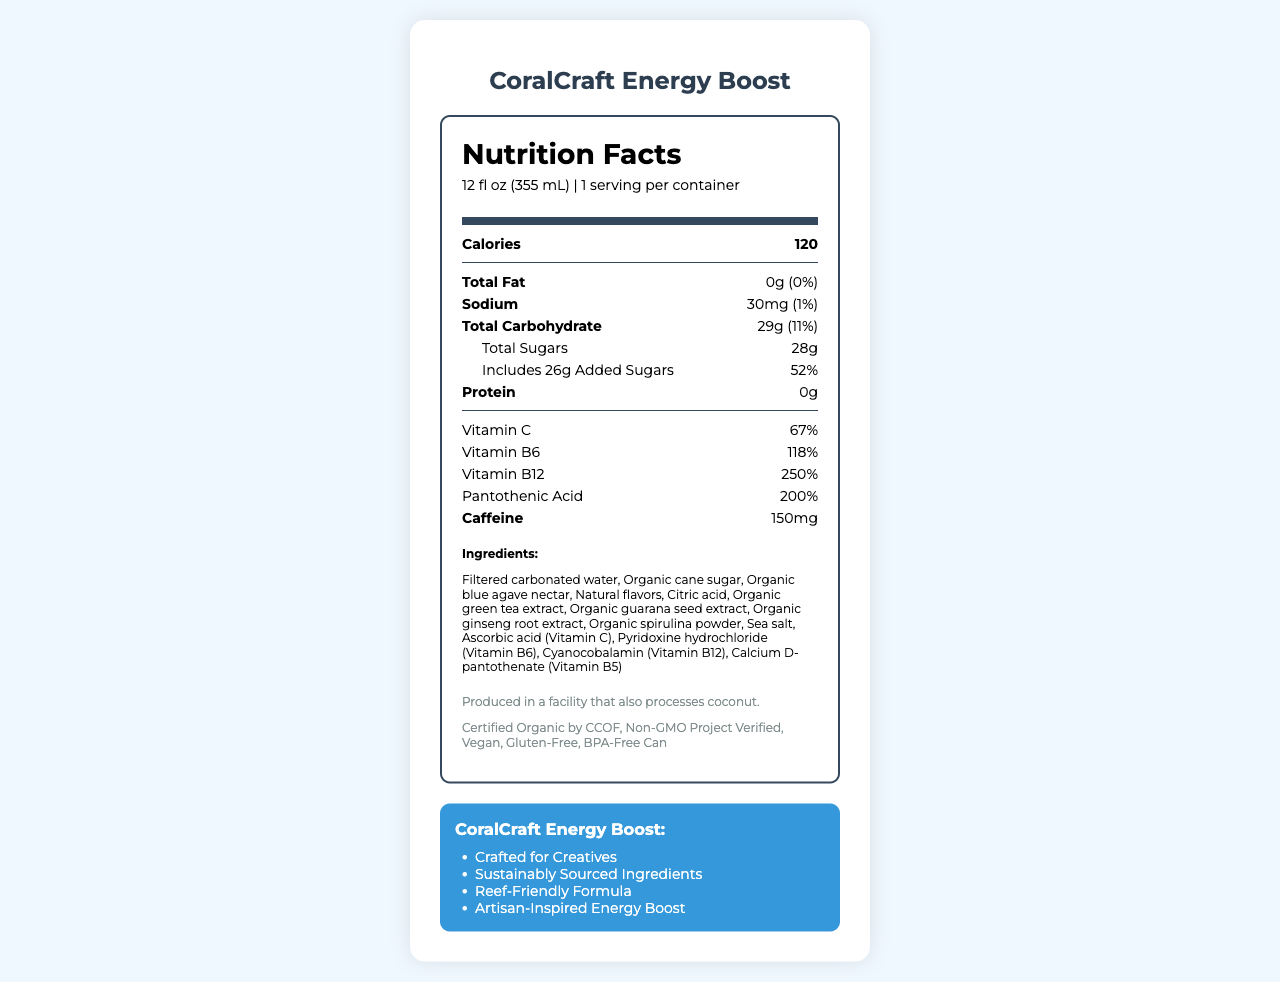What is the serving size of CoralCraft Energy Boost? The serving size is clearly listed at the top of the nutrition label as 12 fl oz (355 mL).
Answer: 12 fl oz (355 mL) How many calories are in one serving of CoralCraft Energy Boost? The calories content per serving is listed prominently on the label as 120.
Answer: 120 What percentage of Daily Value (%DV) for vitamin B12 does one serving of CoralCraft Energy Boost provide? The nutrition label states that one serving contains a 250% Daily Value of vitamin B12.
Answer: 250% What is the amount of caffeine in CoralCraft Energy Boost? The caffeine content is listed towards the bottom of the nutrition label as 150mg.
Answer: 150mg What are the main ingredients in CoralCraft Energy Boost? The ingredients are listed in the document under the heading "Ingredients".
Answer: Filtered carbonated water, Organic cane sugar, Organic blue agave nectar, Natural flavors, Citric acid, Organic green tea extract, Organic guarana seed extract, Organic ginseng root extract, Organic spirulina powder, Sea salt, Ascorbic acid (Vitamin C), Pyridoxine hydrochloride (Vitamin B6), Cyanocobalamin (Vitamin B12), Calcium D-pantothenate (Vitamin B5) How much added sugars does CoralCraft Energy Boost contain? The label denotes that it includes 26g of added sugars.
Answer: 26g Which vitamin provides the highest percentage of Daily Value in CoralCraft Energy Boost? The label shows that vitamin B12 provides a 250% Daily Value, which is the highest among the listed vitamins.
Answer: Vitamin B12 What allergen information is provided about CoralCraft Energy Boost? The allergen information is located at the bottom of the nutrition label stating it is produced in a facility that processes coconut.
Answer: Produced in a facility that also processes coconut. What makes CoralCraft Energy Boost suitable for sustainability-conscious consumers? Under the "marketing claims" section, it is specified that the product uses sustainably sourced ingredients and has a reef-friendly formula.
Answer: Sustainably Sourced Ingredients, Reef-Friendly Formula What is the main purpose of CoralCraft Energy Boost? The marketing claims highlight that it provides an artisan-inspired energy boost.
Answer: Artisan-Inspired Energy Boost How much sodium is in one serving of CoralCraft Energy Boost? A. 5mg B. 30mg C. 50mg D. 100mg According to the nutrition label, there are 30mg of sodium per serving.
Answer: B What percentage of the Daily Value does Vitamin C account for in CoralCraft Energy Boost? A. 20% B. 50% C. 67% D. 100% The nutrition label indicates that Vitamin C provides 67% of the Daily Value per serving.
Answer: C Is CoralCraft Energy Boost gluten-free? The label lists "Gluten-Free" under additional information, confirming that the product is gluten-free.
Answer: Yes Summarize the main aspects of CoralCraft Energy Boost. The summary includes key points about the product’s nutritional content, ingredients, sustainability features, and certifications making it suitable for the target audience.
Answer: CoralCraft Energy Boost is an organic energy drink specially crafted for creative professionals and craftspeople. It provides 120 calories per serving, includes various vitamins like Vitamin C, B6, B12, and Pantothenic Acid at high Daily Values, and contains 150mg of caffeine. The drink is made from sustainably sourced ingredients, is reef-friendly, and is gluten-free, vegan, and non-GMO certified. Which other products are produced in the same facility as CoralCraft Energy Boost? The document mentions that the product is produced in a facility that processes coconut, but it does not give details on other products produced in the same facility.
Answer: Not enough information 